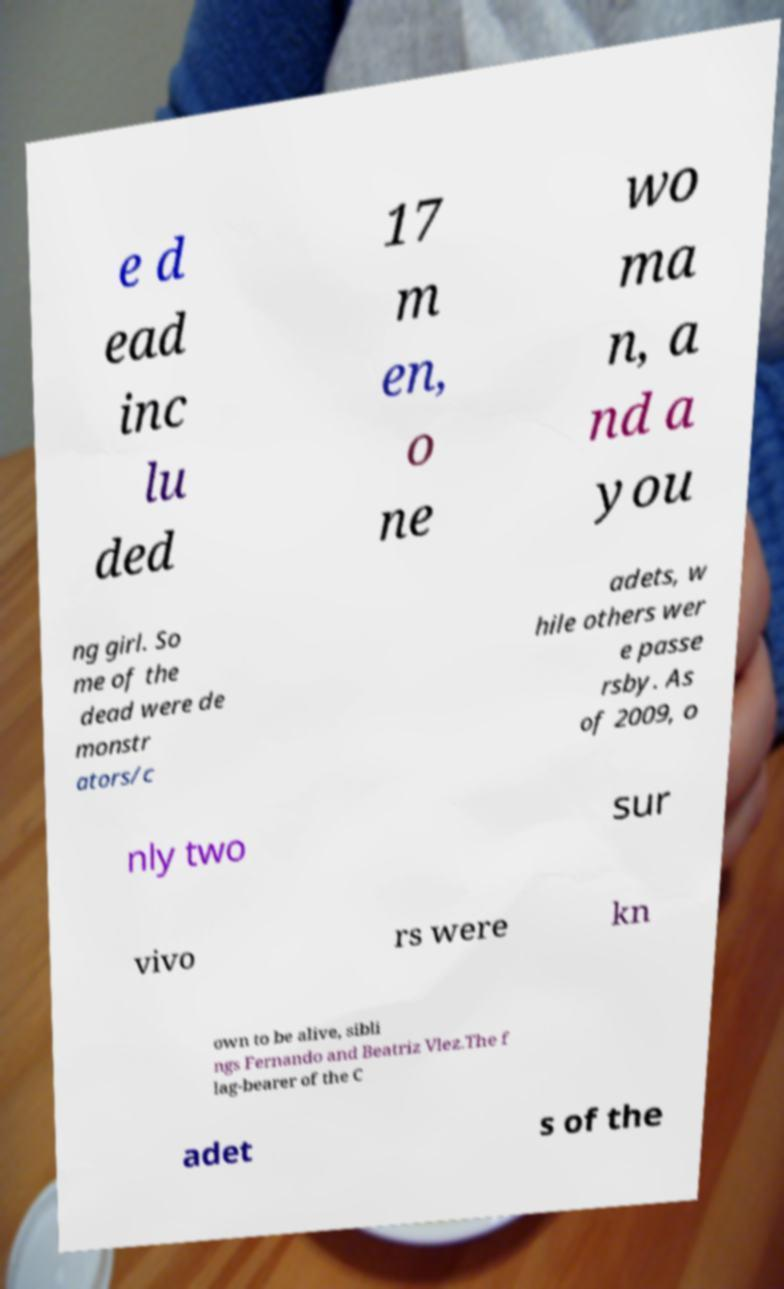Could you extract and type out the text from this image? e d ead inc lu ded 17 m en, o ne wo ma n, a nd a you ng girl. So me of the dead were de monstr ators/c adets, w hile others wer e passe rsby. As of 2009, o nly two sur vivo rs were kn own to be alive, sibli ngs Fernando and Beatriz Vlez.The f lag-bearer of the C adet s of the 